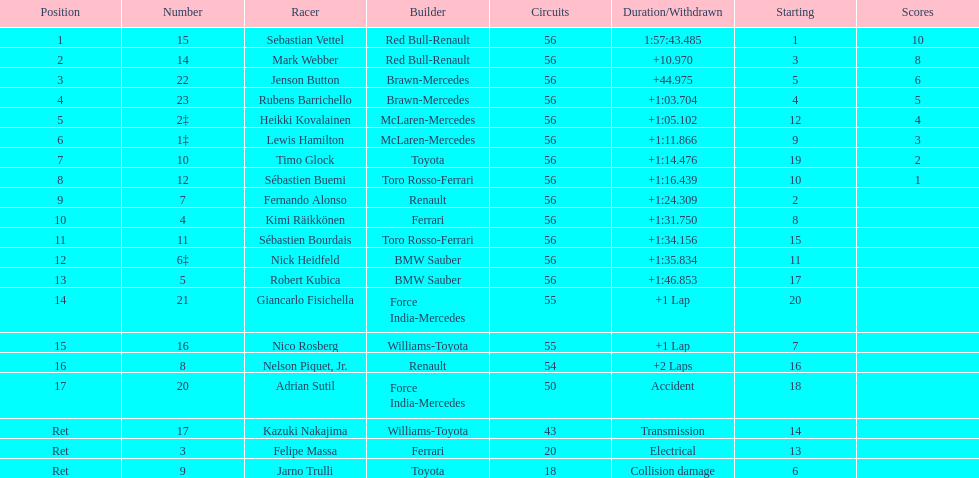Who was the slowest driver to finish the race? Robert Kubica. 